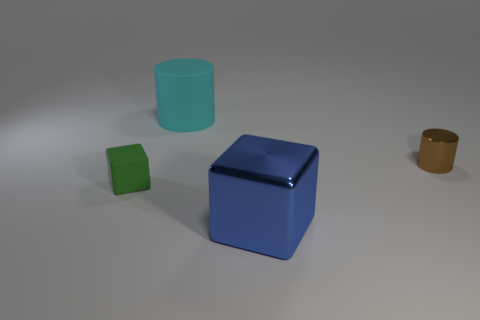How many blue metal objects are in front of the green rubber block?
Offer a terse response. 1. Is the material of the small object that is left of the matte cylinder the same as the large cyan object?
Give a very brief answer. Yes. What number of tiny things are the same material as the large cyan cylinder?
Your answer should be very brief. 1. Are there more brown metal cylinders to the right of the blue metallic thing than large matte cylinders?
Ensure brevity in your answer.  No. Are there any small brown things that have the same shape as the cyan matte thing?
Your answer should be compact. Yes. What number of objects are brown metallic things or big cylinders?
Provide a succinct answer. 2. There is a large thing in front of the matte thing in front of the big cyan thing; how many large metallic blocks are to the right of it?
Ensure brevity in your answer.  0. There is another small thing that is the same shape as the blue object; what is it made of?
Ensure brevity in your answer.  Rubber. What material is the object that is on the left side of the big blue metal block and in front of the large cyan object?
Make the answer very short. Rubber. Is the number of blue blocks that are right of the cyan rubber cylinder less than the number of green objects that are in front of the metal block?
Your answer should be compact. No. 